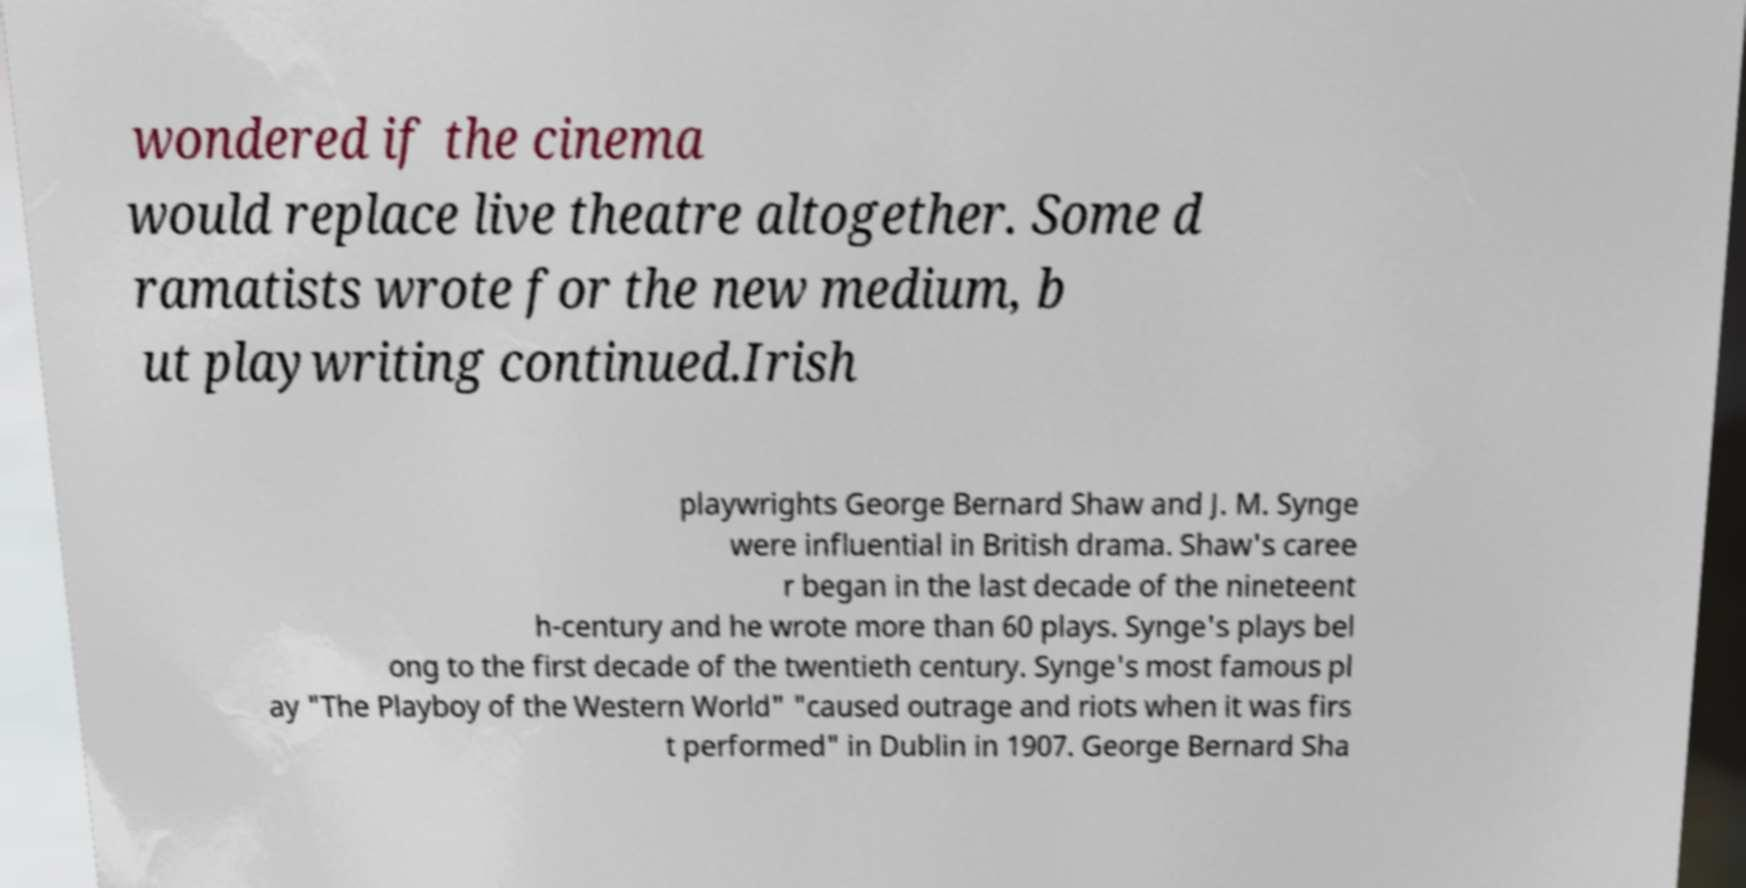Please read and relay the text visible in this image. What does it say? wondered if the cinema would replace live theatre altogether. Some d ramatists wrote for the new medium, b ut playwriting continued.Irish playwrights George Bernard Shaw and J. M. Synge were influential in British drama. Shaw's caree r began in the last decade of the nineteent h-century and he wrote more than 60 plays. Synge's plays bel ong to the first decade of the twentieth century. Synge's most famous pl ay "The Playboy of the Western World" "caused outrage and riots when it was firs t performed" in Dublin in 1907. George Bernard Sha 